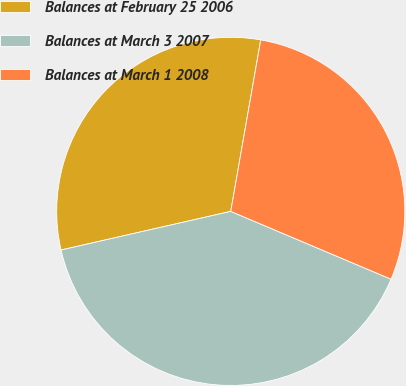Convert chart to OTSL. <chart><loc_0><loc_0><loc_500><loc_500><pie_chart><fcel>Balances at February 25 2006<fcel>Balances at March 3 2007<fcel>Balances at March 1 2008<nl><fcel>31.32%<fcel>40.07%<fcel>28.62%<nl></chart> 